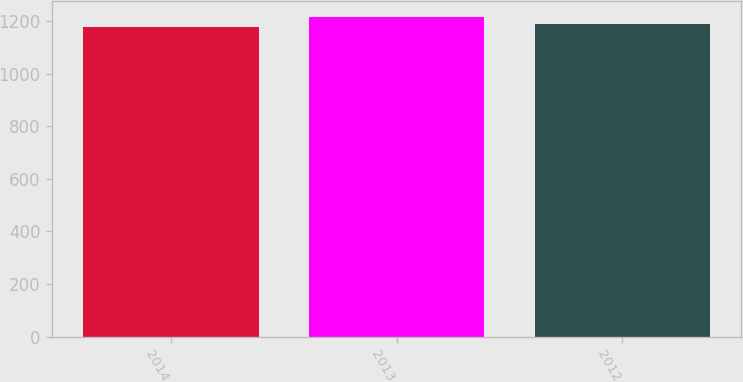Convert chart to OTSL. <chart><loc_0><loc_0><loc_500><loc_500><bar_chart><fcel>2014<fcel>2013<fcel>2012<nl><fcel>1176<fcel>1214<fcel>1190<nl></chart> 